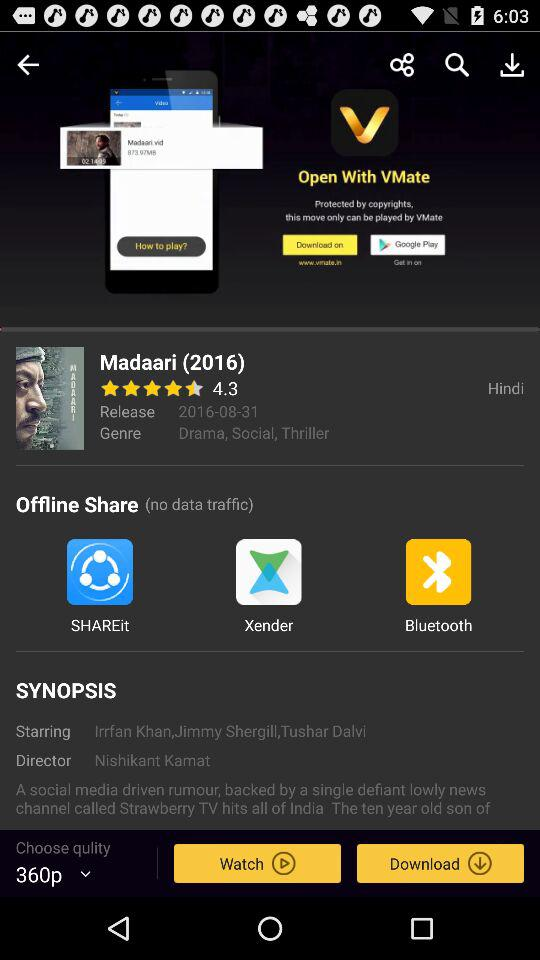What is the name of the director? The name of the director is Nishikant Kamat. 